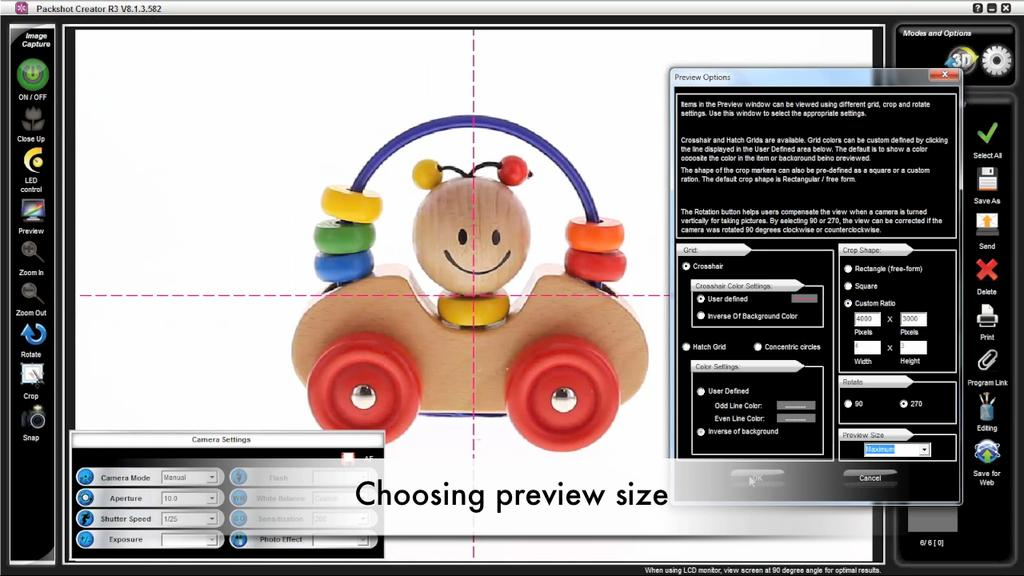What is the main subject of the image? There is a depiction picture in the image. What can be seen in the picture? The picture contains a brown-colored toy. Where is text written on the image? There is text written on the left side, right side, and bottom of the image. What type of rod can be seen in the alley in the image? There is no alley or rod present in the image; it only contains a depiction picture with a brown-colored toy and text. 